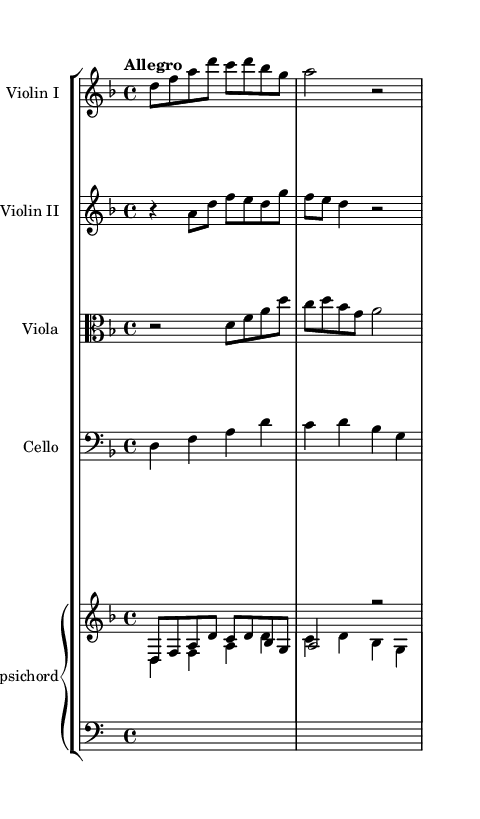What is the key signature of this music? The key signature is determined by the number of sharps or flats indicated at the beginning of the staff. In this case, the key signature shows two sharps (F# and C#), which indicates the music is in D minor.
Answer: D minor What is the time signature of this piece? The time signature is found at the beginning of the piece, indicating how many beats are in each measure. Here, the time signature is 4/4, meaning there are four beats per measure.
Answer: 4/4 What is the tempo marking for this piece? The tempo marking is typically notated at the start of the piece, indicating the speed. Here, the marking is "Allegro," which denotes a fast and lively pace.
Answer: Allegro How many measures are present in the first part for Violin I? To determine the number of measures, we count the individual measures in the Violin I part. In the provided snippet, there are three complete measures visible.
Answer: 3 What instruments are included in this score? The instruments are listed at the beginning of each staff or indicated by the staff group names. Here, the score includes Violin I, Violin II, Viola, Cello, and Harpsichord.
Answer: Violin I, Violin II, Viola, Cello, Harpsichord Which voice is playing the counterpoint in the cello part? Counterpoint involves playing two or more independent melodies together. In the cello part, it's noticeable that the lines interact harmonically and melodically with the other voices, specifically the viola and violin parts, establishing a counterpoint.
Answer: Cello 